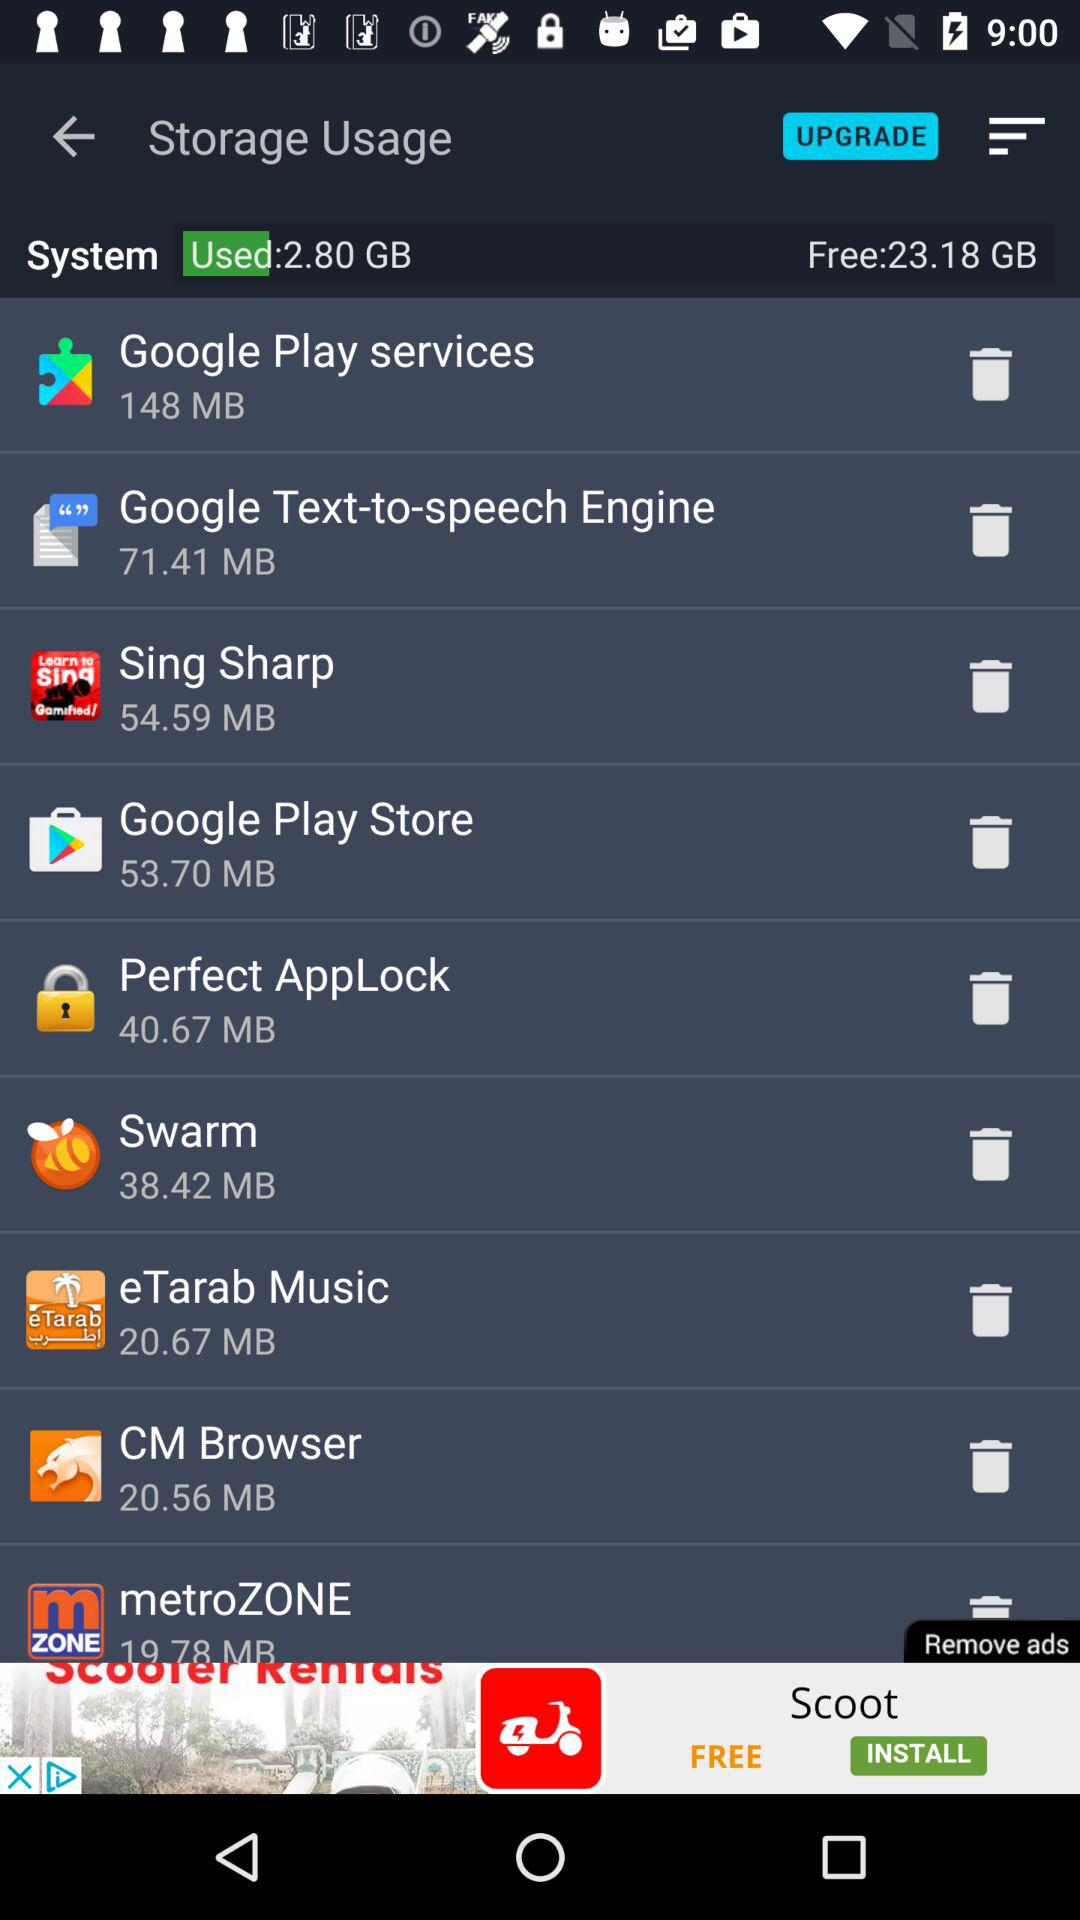What is the size of "Google Play Store" in MB? The size of "Google Play Store" is 53.70 MB. 